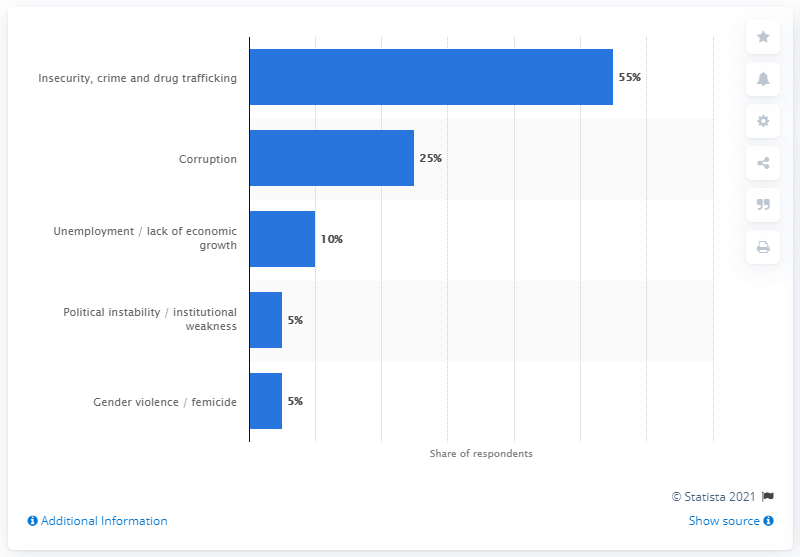Identify some key points in this picture. The second most frequently cited issue in a survey conducted in June and July of 2019 was corruption. 